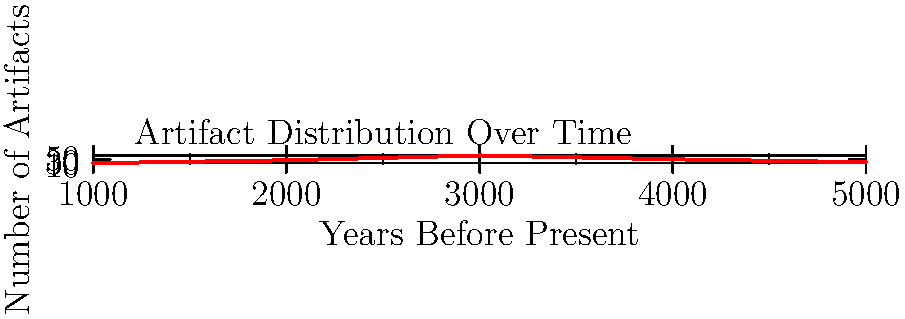The graph shows the distribution of artifacts across different time periods. Based on this empirical evidence, which of the following statements best challenges the theoretical physicist's assumption about time travel to the past? To answer this question, we need to analyze the graph and its implications for time travel theories:

1. The x-axis represents "Years Before Present," ranging from 1000 to 5000 years ago.
2. The y-axis shows the "Number of Artifacts" found for each time period.
3. The graph shows a clear peak in artifact numbers around 3000 years ago.

Step-by-step analysis:
1. If time travel to the past were possible and frequent, we would expect a more uniform distribution of artifacts across all time periods.
2. The graph shows a non-uniform distribution, with a clear peak and fewer artifacts in both earlier and later periods.
3. This distribution suggests a natural progression of human activity and artifact creation over time, rather than interference from time travelers.
4. The decline in artifacts after the peak could be explained by natural degradation over time, not by removal or alteration by time travelers.
5. The gradual increase leading up to the peak suggests a natural growth of population and technology, not sudden appearances of advanced artifacts from the future.

This empirical evidence challenges time travel assumptions because it shows a pattern consistent with natural historical progression rather than the random or uniform distribution we might expect if time travelers were influencing the past.
Answer: Non-uniform artifact distribution consistent with natural historical progression 